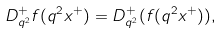Convert formula to latex. <formula><loc_0><loc_0><loc_500><loc_500>D _ { q ^ { 2 } } ^ { + } f ( q ^ { 2 } x ^ { + } ) = D _ { q ^ { 2 } } ^ { + } ( f ( q ^ { 2 } x ^ { + } ) ) ,</formula> 